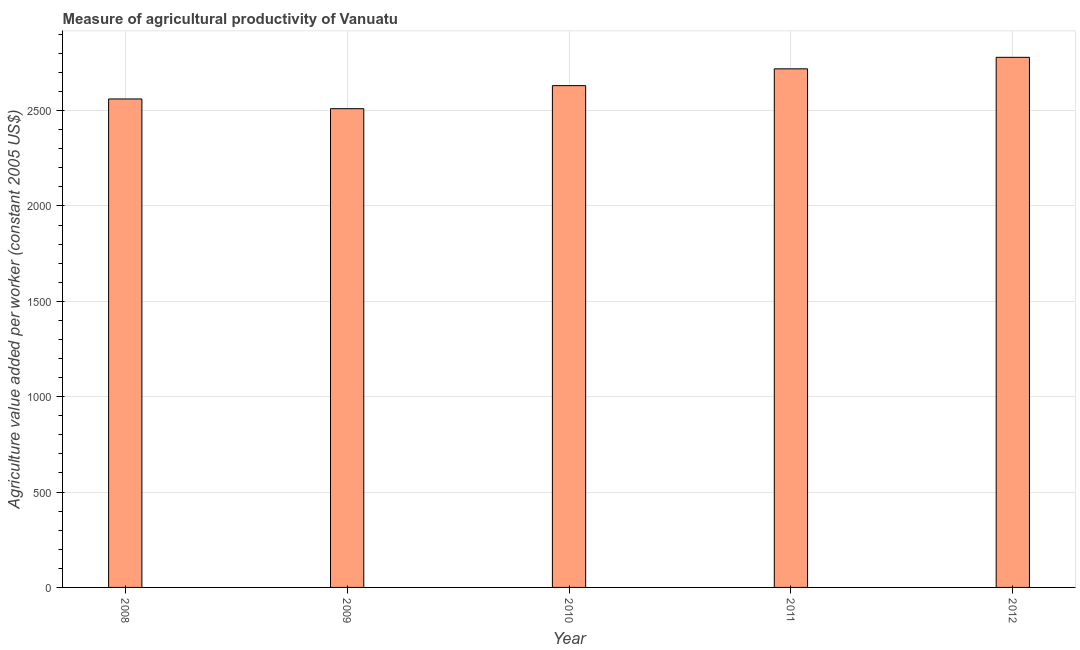Does the graph contain any zero values?
Give a very brief answer. No. Does the graph contain grids?
Your response must be concise. Yes. What is the title of the graph?
Keep it short and to the point. Measure of agricultural productivity of Vanuatu. What is the label or title of the Y-axis?
Give a very brief answer. Agriculture value added per worker (constant 2005 US$). What is the agriculture value added per worker in 2011?
Offer a terse response. 2718.66. Across all years, what is the maximum agriculture value added per worker?
Provide a short and direct response. 2779.02. Across all years, what is the minimum agriculture value added per worker?
Give a very brief answer. 2509.74. In which year was the agriculture value added per worker maximum?
Give a very brief answer. 2012. In which year was the agriculture value added per worker minimum?
Your response must be concise. 2009. What is the sum of the agriculture value added per worker?
Give a very brief answer. 1.32e+04. What is the difference between the agriculture value added per worker in 2009 and 2010?
Your response must be concise. -120.89. What is the average agriculture value added per worker per year?
Your answer should be compact. 2639.76. What is the median agriculture value added per worker?
Your answer should be compact. 2630.63. What is the ratio of the agriculture value added per worker in 2009 to that in 2010?
Your response must be concise. 0.95. What is the difference between the highest and the second highest agriculture value added per worker?
Your answer should be compact. 60.35. What is the difference between the highest and the lowest agriculture value added per worker?
Your response must be concise. 269.28. In how many years, is the agriculture value added per worker greater than the average agriculture value added per worker taken over all years?
Your answer should be very brief. 2. How many bars are there?
Provide a short and direct response. 5. How many years are there in the graph?
Provide a succinct answer. 5. What is the difference between two consecutive major ticks on the Y-axis?
Your answer should be compact. 500. What is the Agriculture value added per worker (constant 2005 US$) in 2008?
Provide a short and direct response. 2560.78. What is the Agriculture value added per worker (constant 2005 US$) of 2009?
Your answer should be compact. 2509.74. What is the Agriculture value added per worker (constant 2005 US$) in 2010?
Make the answer very short. 2630.63. What is the Agriculture value added per worker (constant 2005 US$) in 2011?
Ensure brevity in your answer.  2718.66. What is the Agriculture value added per worker (constant 2005 US$) of 2012?
Your answer should be very brief. 2779.02. What is the difference between the Agriculture value added per worker (constant 2005 US$) in 2008 and 2009?
Give a very brief answer. 51.04. What is the difference between the Agriculture value added per worker (constant 2005 US$) in 2008 and 2010?
Offer a very short reply. -69.85. What is the difference between the Agriculture value added per worker (constant 2005 US$) in 2008 and 2011?
Ensure brevity in your answer.  -157.89. What is the difference between the Agriculture value added per worker (constant 2005 US$) in 2008 and 2012?
Provide a succinct answer. -218.24. What is the difference between the Agriculture value added per worker (constant 2005 US$) in 2009 and 2010?
Provide a short and direct response. -120.89. What is the difference between the Agriculture value added per worker (constant 2005 US$) in 2009 and 2011?
Offer a terse response. -208.93. What is the difference between the Agriculture value added per worker (constant 2005 US$) in 2009 and 2012?
Your answer should be compact. -269.28. What is the difference between the Agriculture value added per worker (constant 2005 US$) in 2010 and 2011?
Your answer should be compact. -88.03. What is the difference between the Agriculture value added per worker (constant 2005 US$) in 2010 and 2012?
Your answer should be very brief. -148.39. What is the difference between the Agriculture value added per worker (constant 2005 US$) in 2011 and 2012?
Provide a succinct answer. -60.35. What is the ratio of the Agriculture value added per worker (constant 2005 US$) in 2008 to that in 2011?
Your answer should be very brief. 0.94. What is the ratio of the Agriculture value added per worker (constant 2005 US$) in 2008 to that in 2012?
Give a very brief answer. 0.92. What is the ratio of the Agriculture value added per worker (constant 2005 US$) in 2009 to that in 2010?
Offer a terse response. 0.95. What is the ratio of the Agriculture value added per worker (constant 2005 US$) in 2009 to that in 2011?
Provide a short and direct response. 0.92. What is the ratio of the Agriculture value added per worker (constant 2005 US$) in 2009 to that in 2012?
Provide a succinct answer. 0.9. What is the ratio of the Agriculture value added per worker (constant 2005 US$) in 2010 to that in 2011?
Offer a terse response. 0.97. What is the ratio of the Agriculture value added per worker (constant 2005 US$) in 2010 to that in 2012?
Keep it short and to the point. 0.95. 